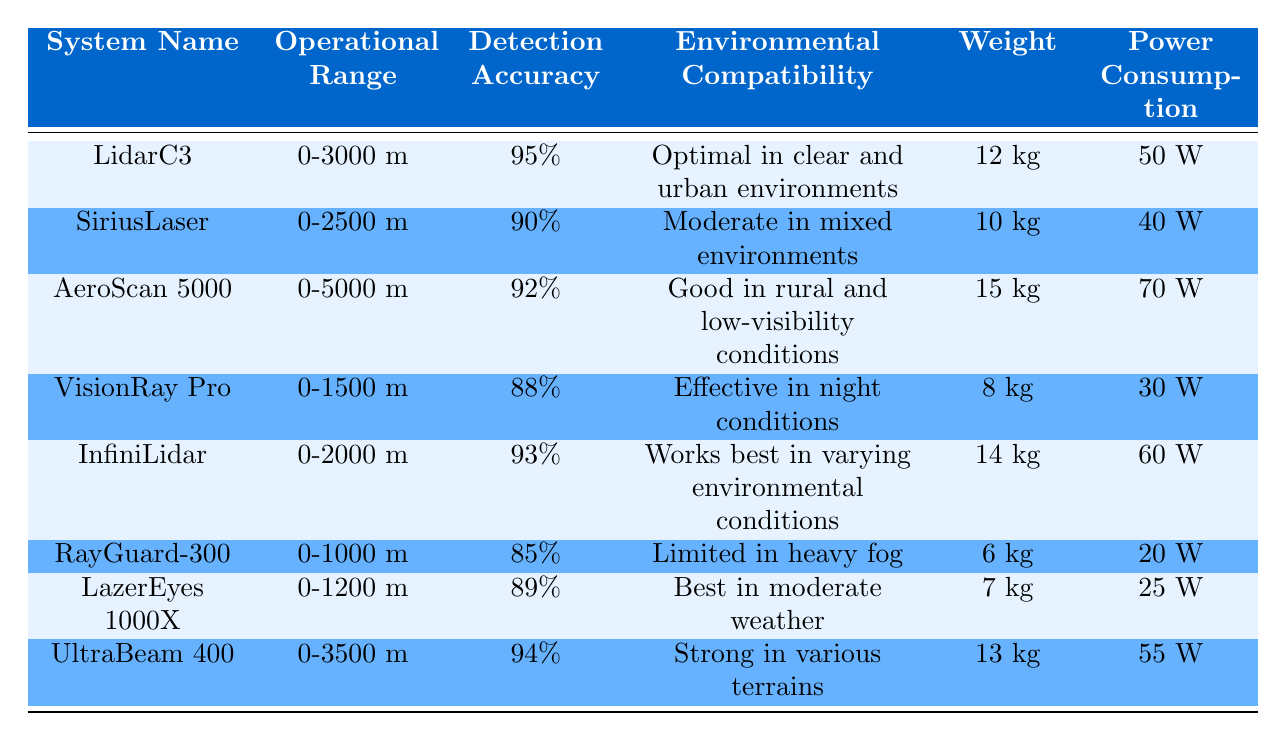What is the operational range of LidarC3? The operational range of LidarC3 is explicitly stated in the table. It is listed under the "Operational Range" column corresponding to the "System Name" LidarC3.
Answer: 0-3000 meters Which system has the highest detection accuracy? By comparing the "Detection Accuracy" values in the table, we identify that LidarC3 has the highest value at 95%, as it is the largest percentage listed in the column.
Answer: LidarC3 Is the weight of RayGuard-300 less than 10 kg? The weight of RayGuard-300 is provided in the table, where it is listed as 6 kg. Since 6 kg is less than 10 kg, the answer is true.
Answer: Yes What is the average weight of the laser detection systems? To calculate the average weight, we sum the weights from all systems (12+10+15+8+14+6+7+13) which equals 85 kg. Then we divide by the total number of systems, which is 8, giving us an average weight of 10.625 kg.
Answer: 10.625 kg Is InfiniLidar optimal in clear and urban environments? Looking at the "Environmental Compatibility" column for InfiniLidar, it indicates it works best in varying environmental conditions, not specifically clear and urban environments, hence the answer is false.
Answer: No Which systems have an operational range greater than 2500 meters? We check the "Operational Range" column and identify the systems. AeroScan 5000 (0-5000 meters) and UltraBeam 400 (0-3500 meters) both exceed 2500 meters, while others do not.
Answer: AeroScan 5000, UltraBeam 400 What is the detection accuracy of the system with the lowest power consumption? We first need to find the least power consumption, which is 20 W for RayGuard-300. We then check its detection accuracy in the table, which is 85%.
Answer: 85% Out of all systems, which has the least operational range and what is it? The table lists the operational ranges, and by inspecting, we see RayGuard-300 has the least operational range at 0-1000 meters.
Answer: RayGuard-300, 0-1000 meters 